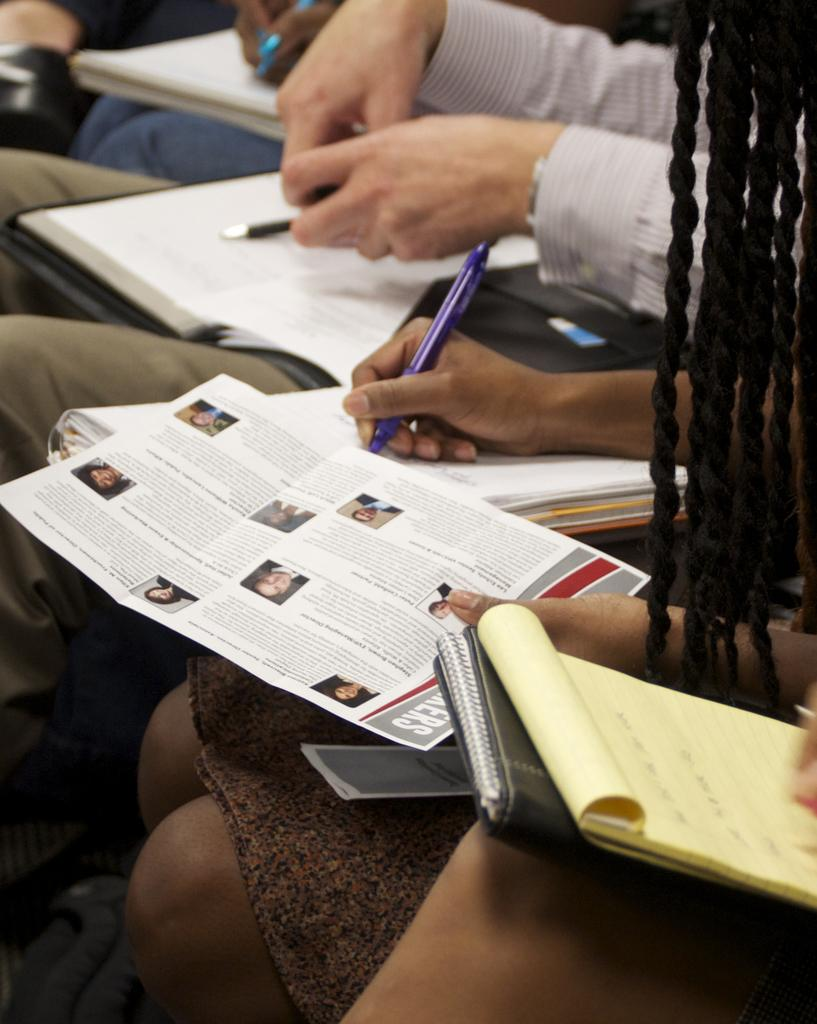Who is present in the image? There are people in the image. What are the people doing in the image? The people are sitting. What objects are the people holding in the image? The people are holding books, pens, and posters. What type of brake can be seen on the poster held by one of the people in the image? There is no brake visible on any of the posters held by the people in the image. 